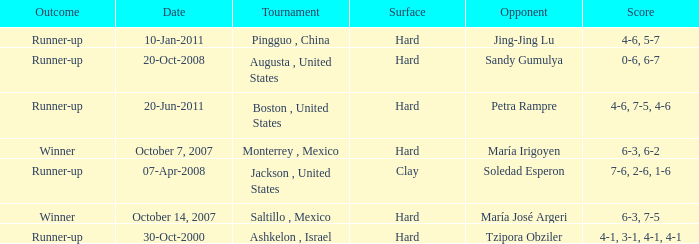What was the outcome when Jing-Jing Lu was the opponent? Runner-up. 